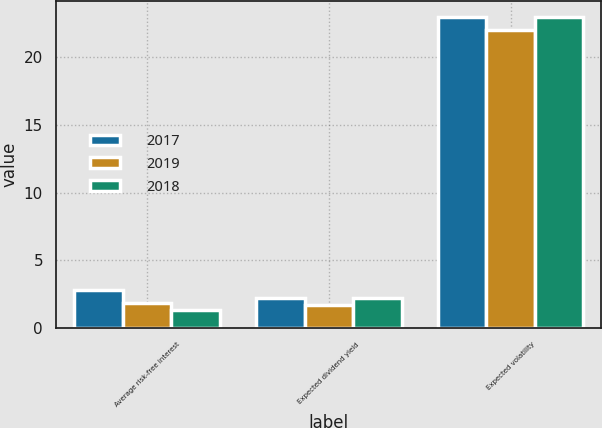Convert chart. <chart><loc_0><loc_0><loc_500><loc_500><stacked_bar_chart><ecel><fcel>Average risk-free interest<fcel>Expected dividend yield<fcel>Expected volatility<nl><fcel>2017<fcel>2.77<fcel>2.24<fcel>23<nl><fcel>2019<fcel>1.88<fcel>1.72<fcel>22<nl><fcel>2018<fcel>1.35<fcel>2.2<fcel>23<nl></chart> 